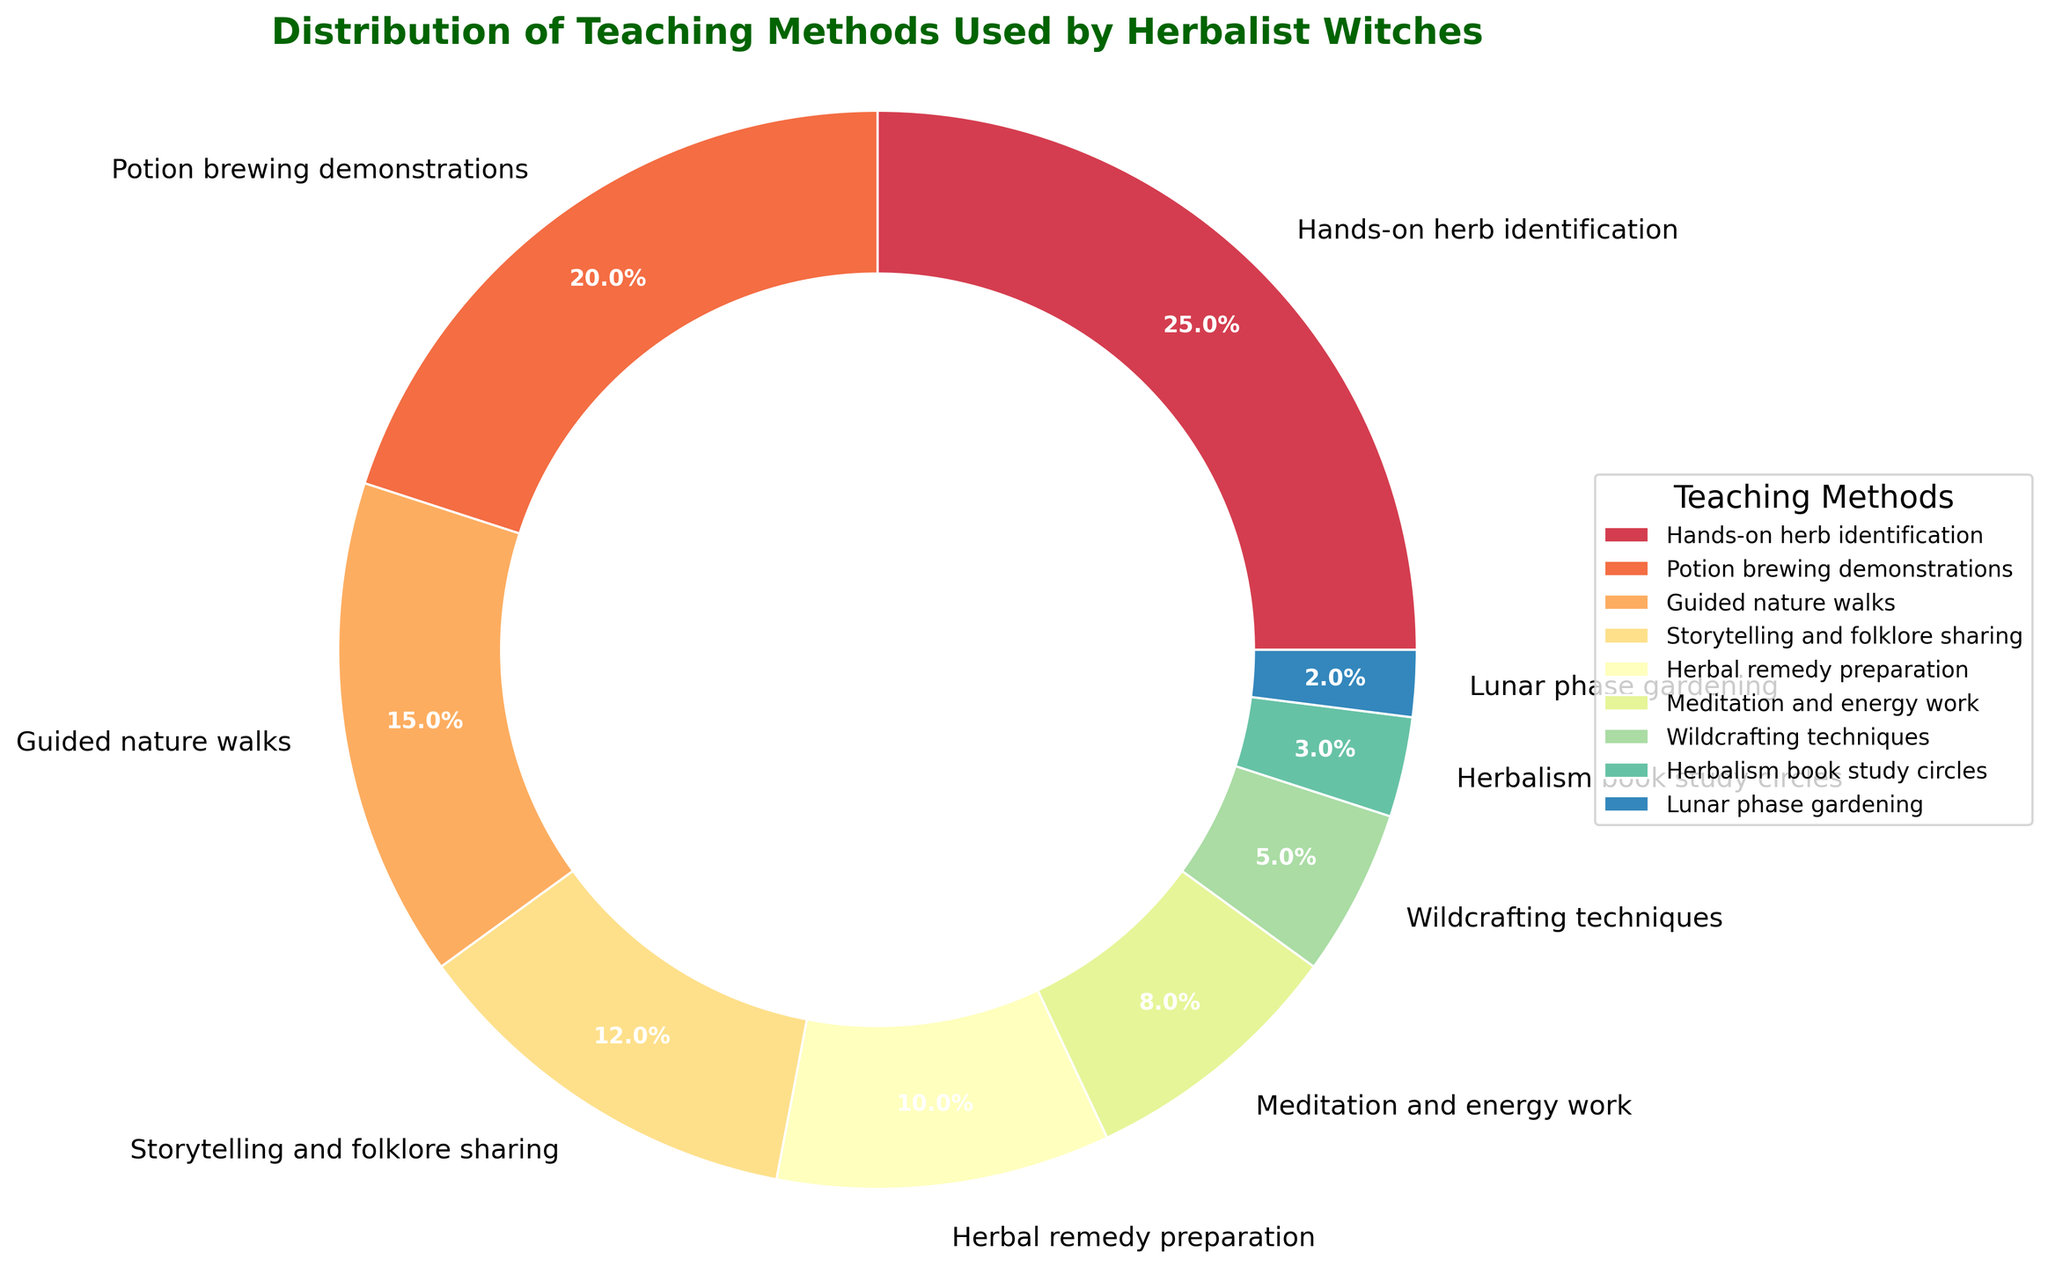What teaching method is the most commonly used by herbalist witches in workshops? By examining the pie chart, the section with the largest percentage is the "Hands-on herb identification" with 25%.
Answer: Hands-on herb identification Which teaching method is the least commonly used, and what is its percentage? The smallest section of the pie chart corresponds to "Lunar phase gardening" with 2%.
Answer: Lunar phase gardening, 2% Compare the usage of "Potion brewing demonstrations" and "Herbal remedy preparation" methods. Which one is used more and by how much? "Potion brewing demonstrations" occupies 20% of the chart, while "Herbal remedy preparation" accounts for 10%. Subtracting these percentages, 20% - 10% = 10%, shows "Potion brewing demonstrations" is more used by 10%.
Answer: Potion brewing demonstrations, 10% What is the combined percentage of the three least used teaching methods? The three least used methods are "Lunar phase gardening" (2%), "Herbalism book study circles" (3%), and "Wildcrafting techniques" (5%). Adding these together, 2% + 3% + 5% = 10%.
Answer: 10% How do the percentages of "Storytelling and folklore sharing" and "Meditation and energy work" compare? Which is more, and by what fraction? "Storytelling and folklore sharing" is 12% and "Meditation and energy work" is 8%. The difference is 12% - 8% = 4%. The fraction is 4% out of the total 100%, so 4/100 = 1/25 or 0.04.
Answer: Storytelling and folklore sharing by 4% If we combine "Hands-on herb identification" and "Potion brewing demonstrations," what is their total percentage of teaching methods used? Adding these percentages: 25% (Hands-on herb identification) + 20% (Potion brewing demonstrations) = 45%.
Answer: 45% Which method is equally distanced between "Guided nature walks" and "Storytelling and folklore sharing" in percentage terms, and what is that intermediary method? "Guided nature walks" is 15%, and "Storytelling and folklore sharing" is 12%. Mid-point is (15% + 12%) / 2 = 13.5%. The closest to this is "Herbal remedy preparation" at 10% which fits our criteria best considering the list of methods.
Answer: Herbal remedy preparation, 10% How does the percentage of "Wildcrafting techniques" compare with "Guided nature walks"? Express it as a percentage of the latter. "Wildcrafting techniques" is 5%, "Guided nature walks" is 15%. Ratio - 5% / 15% = 1/3 or approximately 33.33%.
Answer: 33.33% What is the total percentage of methods that are used less than 10%? Summing "Wildcrafting techniques" (5%), "Herbalism book study circles" (3%), and "Lunar phase gardening" (2%) gives 5% + 3% + 2% = 10%.
Answer: 10% 